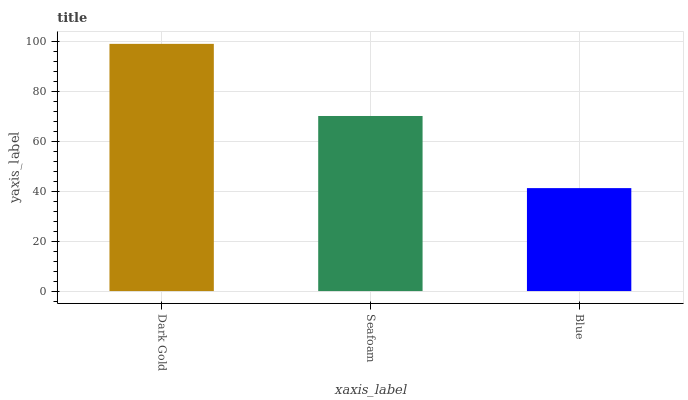Is Blue the minimum?
Answer yes or no. Yes. Is Dark Gold the maximum?
Answer yes or no. Yes. Is Seafoam the minimum?
Answer yes or no. No. Is Seafoam the maximum?
Answer yes or no. No. Is Dark Gold greater than Seafoam?
Answer yes or no. Yes. Is Seafoam less than Dark Gold?
Answer yes or no. Yes. Is Seafoam greater than Dark Gold?
Answer yes or no. No. Is Dark Gold less than Seafoam?
Answer yes or no. No. Is Seafoam the high median?
Answer yes or no. Yes. Is Seafoam the low median?
Answer yes or no. Yes. Is Blue the high median?
Answer yes or no. No. Is Blue the low median?
Answer yes or no. No. 